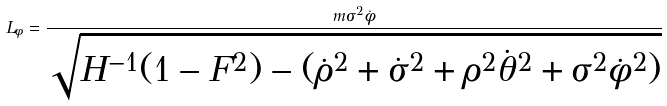Convert formula to latex. <formula><loc_0><loc_0><loc_500><loc_500>L _ { \phi } = \frac { m \sigma ^ { 2 } \dot { \phi } } { \sqrt { H ^ { - 1 } ( 1 - F ^ { 2 } ) - ( \dot { \rho } ^ { 2 } + \dot { \sigma } ^ { 2 } + \rho ^ { 2 } \dot { \theta } ^ { 2 } + \sigma ^ { 2 } \dot { \phi } ^ { 2 } ) } }</formula> 